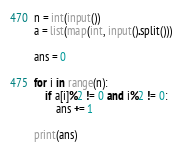<code> <loc_0><loc_0><loc_500><loc_500><_Python_>n = int(input())
a = list(map(int, input().split()))

ans = 0

for i in range(n):
    if a[i]%2 != 0 and i%2 != 0:
        ans += 1

print(ans)
</code> 